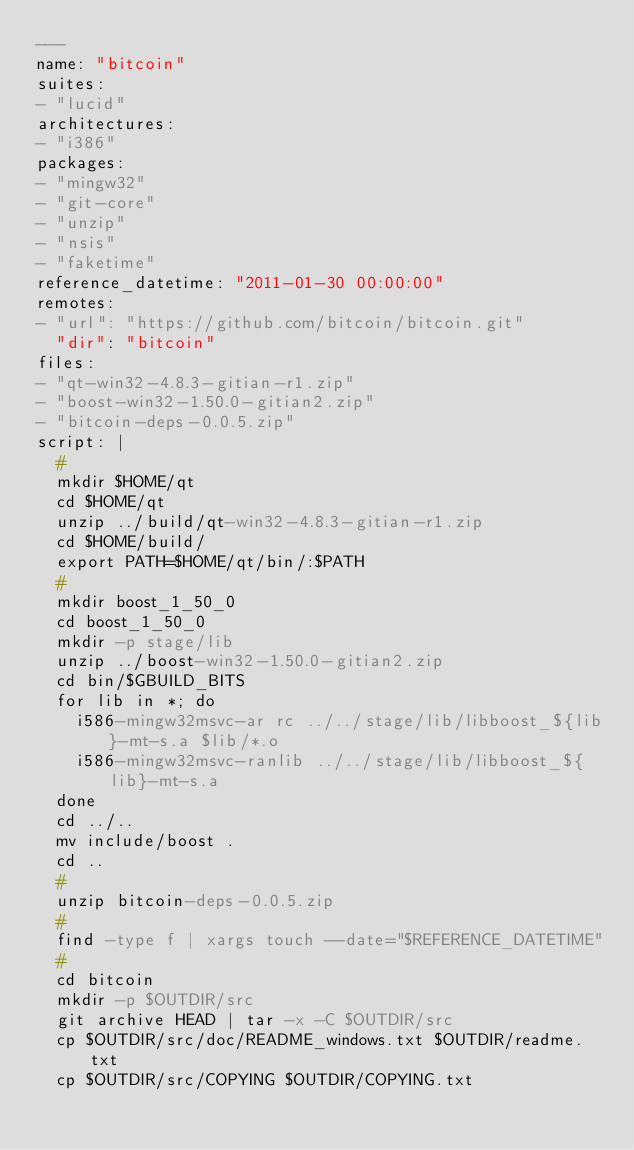<code> <loc_0><loc_0><loc_500><loc_500><_YAML_>---
name: "bitcoin"
suites:
- "lucid"
architectures:
- "i386"
packages:
- "mingw32"
- "git-core"
- "unzip"
- "nsis"
- "faketime"
reference_datetime: "2011-01-30 00:00:00"
remotes:
- "url": "https://github.com/bitcoin/bitcoin.git"
  "dir": "bitcoin"
files:
- "qt-win32-4.8.3-gitian-r1.zip"
- "boost-win32-1.50.0-gitian2.zip"
- "bitcoin-deps-0.0.5.zip"
script: |
  #
  mkdir $HOME/qt
  cd $HOME/qt
  unzip ../build/qt-win32-4.8.3-gitian-r1.zip
  cd $HOME/build/
  export PATH=$HOME/qt/bin/:$PATH
  #
  mkdir boost_1_50_0
  cd boost_1_50_0
  mkdir -p stage/lib
  unzip ../boost-win32-1.50.0-gitian2.zip
  cd bin/$GBUILD_BITS
  for lib in *; do
    i586-mingw32msvc-ar rc ../../stage/lib/libboost_${lib}-mt-s.a $lib/*.o
    i586-mingw32msvc-ranlib ../../stage/lib/libboost_${lib}-mt-s.a
  done
  cd ../..
  mv include/boost .
  cd ..
  #
  unzip bitcoin-deps-0.0.5.zip
  #
  find -type f | xargs touch --date="$REFERENCE_DATETIME"
  #
  cd bitcoin
  mkdir -p $OUTDIR/src
  git archive HEAD | tar -x -C $OUTDIR/src
  cp $OUTDIR/src/doc/README_windows.txt $OUTDIR/readme.txt
  cp $OUTDIR/src/COPYING $OUTDIR/COPYING.txt</code> 